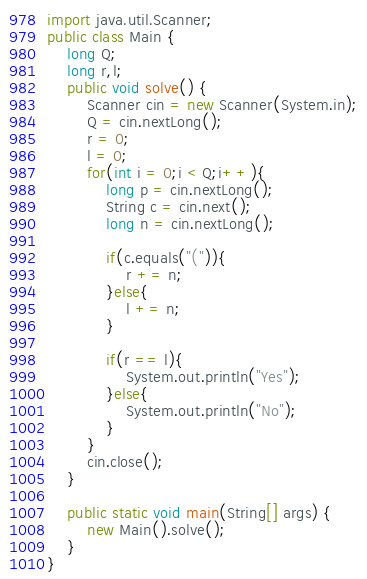<code> <loc_0><loc_0><loc_500><loc_500><_Java_>import java.util.Scanner;
public class Main {
	long Q;
	long r,l;
	public void solve() {
		Scanner cin = new Scanner(System.in);
		Q = cin.nextLong();
		r = 0;
		l = 0;
		for(int i = 0;i < Q;i++){
			long p = cin.nextLong();
			String c = cin.next();
			long n = cin.nextLong();
			
			if(c.equals("(")){
				r += n;
			}else{
				l += n;
			}
			
			if(r == l){
				System.out.println("Yes");
			}else{
				System.out.println("No");
			}
		}
		cin.close();
	}
 
	public static void main(String[] args) {
		new Main().solve();
	}
}</code> 